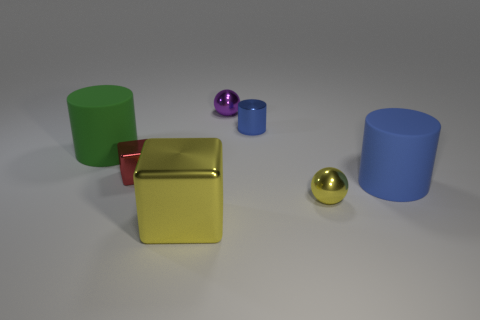How big is the cylinder that is in front of the large cylinder that is left of the yellow metallic cube?
Give a very brief answer. Large. How many objects are big yellow shiny things or things that are behind the green cylinder?
Make the answer very short. 3. How many other metallic objects are the same shape as the green thing?
Your response must be concise. 1. What material is the green object that is the same size as the yellow cube?
Provide a short and direct response. Rubber. What is the size of the shiny cube that is behind the yellow thing that is on the left side of the metallic ball on the right side of the metal cylinder?
Offer a terse response. Small. There is a metal cube that is in front of the small yellow thing; does it have the same color as the sphere in front of the blue metal object?
Your response must be concise. Yes. What number of green things are either spheres or cylinders?
Offer a very short reply. 1. What number of objects have the same size as the yellow block?
Your answer should be very brief. 2. Is the material of the blue thing on the right side of the small cylinder the same as the tiny cylinder?
Make the answer very short. No. There is a big rubber cylinder that is on the right side of the tiny yellow shiny sphere; are there any rubber things on the left side of it?
Keep it short and to the point. Yes. 